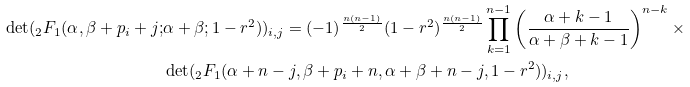Convert formula to latex. <formula><loc_0><loc_0><loc_500><loc_500>\det ( _ { 2 } F _ { 1 } ( \alpha , \beta + p _ { i } + j ; & \alpha + \beta ; 1 - r ^ { 2 } ) ) _ { i , j } = ( - 1 ) ^ { \frac { n ( n - 1 ) } { 2 } } ( 1 - r ^ { 2 } ) ^ { \frac { n ( n - 1 ) } { 2 } } \prod _ { k = 1 } ^ { n - 1 } \left ( \frac { \alpha + k - 1 } { \alpha + \beta + k - 1 } \right ) ^ { n - k } \times \\ & \det ( _ { 2 } F _ { 1 } ( \alpha + n - j , \beta + p _ { i } + n , \alpha + \beta + n - j , 1 - r ^ { 2 } ) ) _ { i , j } ,</formula> 